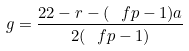Convert formula to latex. <formula><loc_0><loc_0><loc_500><loc_500>g = \frac { 2 2 - r - ( \ f p - 1 ) a } { 2 ( \ f p - 1 ) }</formula> 